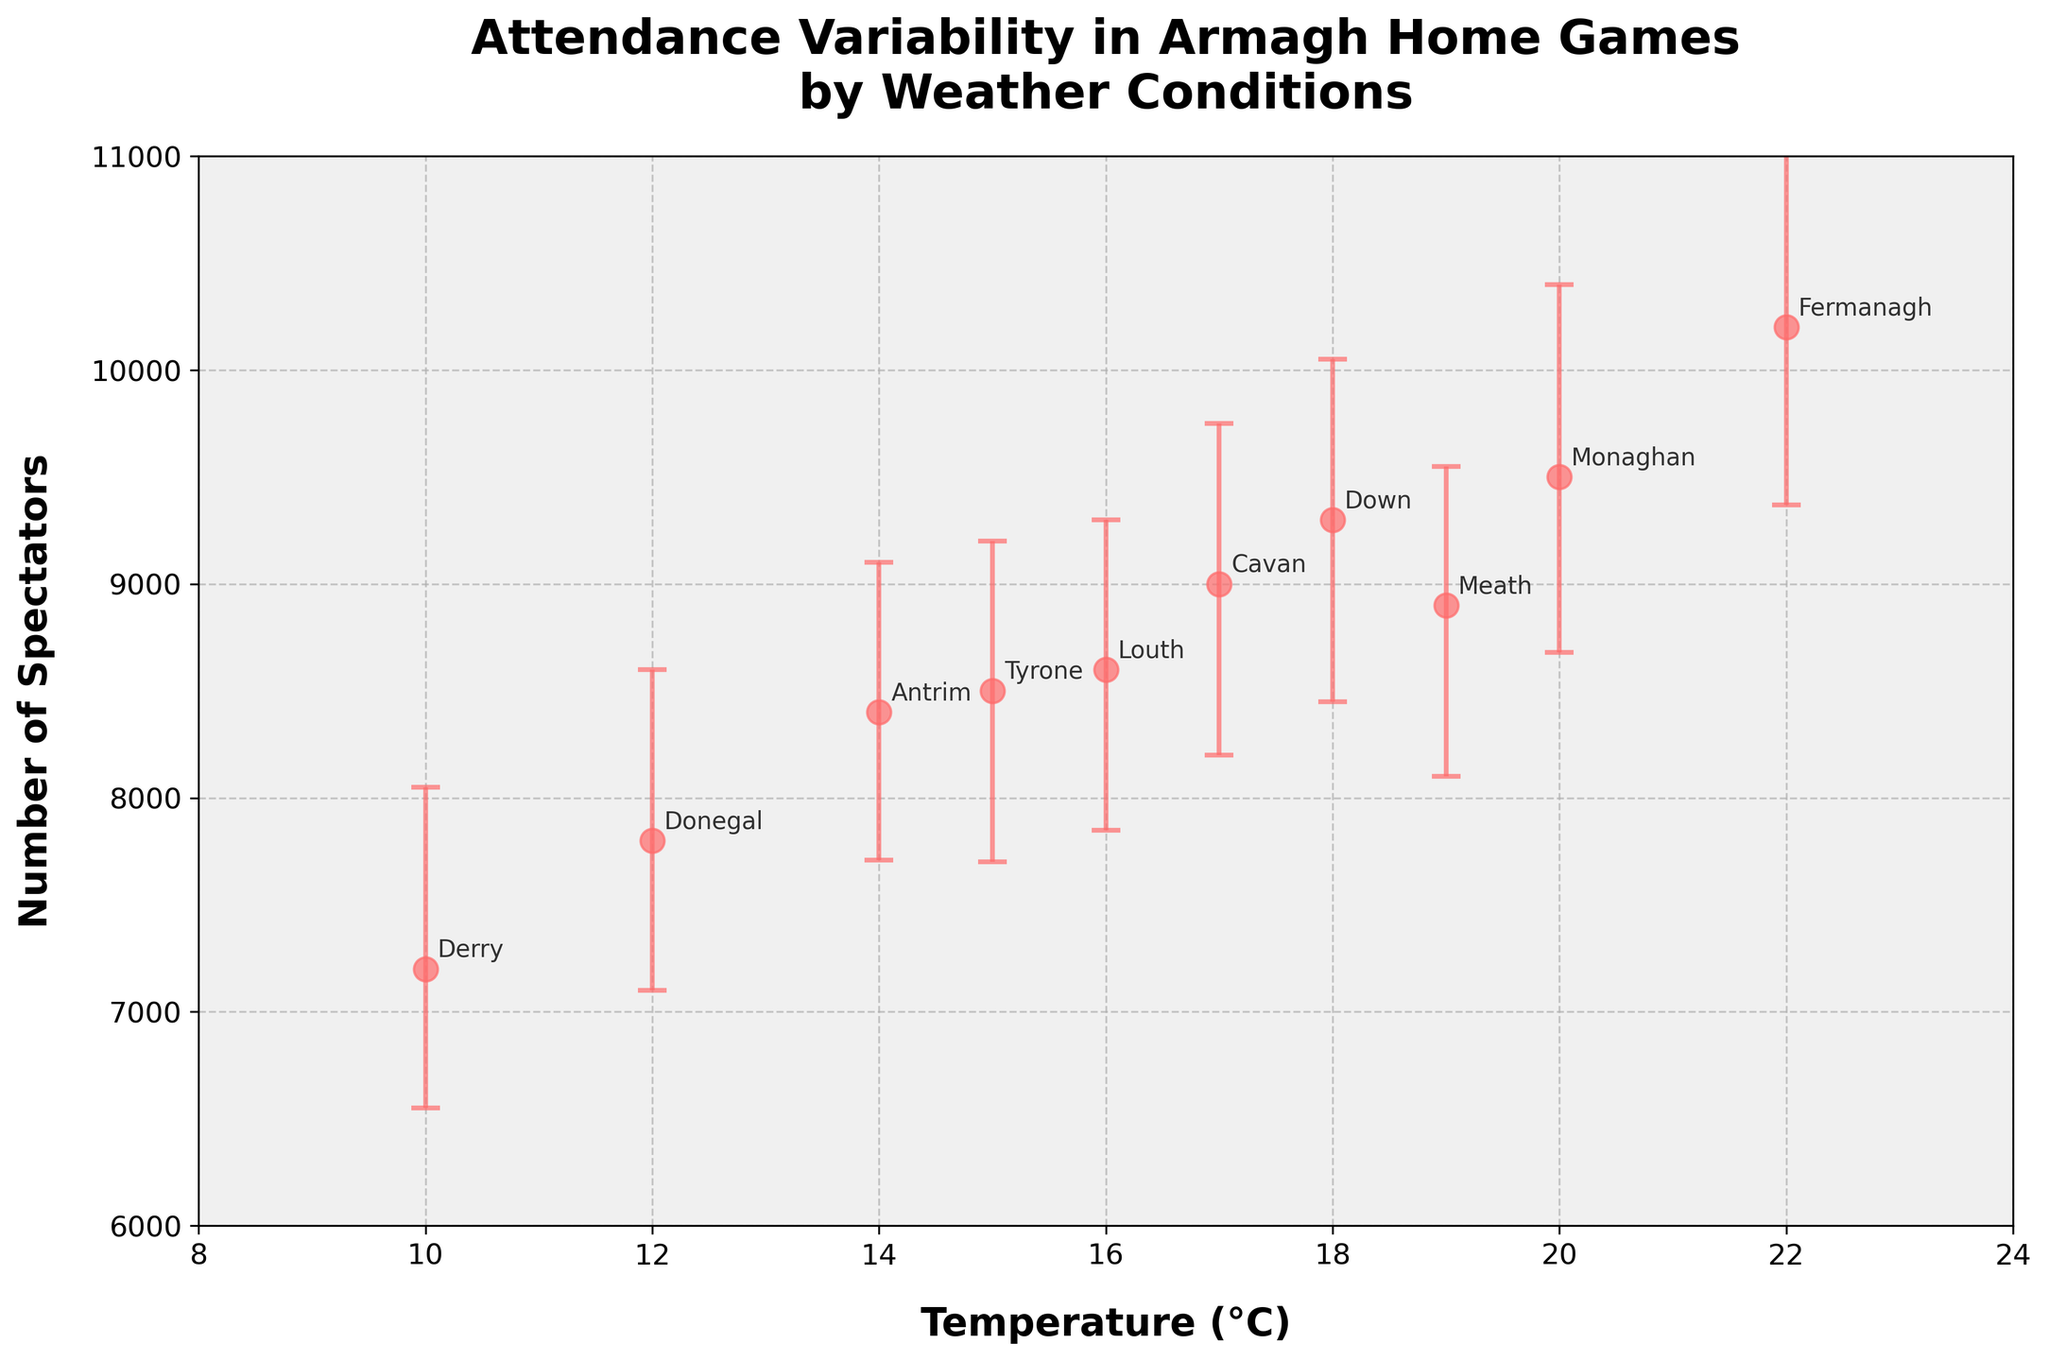What is the title of the plot? The title is found at the top of the figure, summarizing the main content or focus of the plot. Here, it is clearly stated in bold, larger font.
Answer: Attendance Variability in Armagh Home Games by Weather Conditions What is the highest number of spectators recorded, and at what temperature did this occur? Identify the point with the highest y-coordinate (Number of Spectators), then locate its corresponding x-coordinate (Temperature).
Answer: 10200, 22°C What is the general trend between temperature and the number of spectators? Observe the scatter points and see if there's a pattern. Generally, as temperature increases, the number of spectators also increases.
Answer: Positive correlation Which game had the lowest attendance and at what temperature? Look for the point with the lowest y-coordinate (Number of Spectators) and find its label and x-coordinate (Temperature). The game vs. Derry has the lowest attendance.
Answer: Armagh vs. Derry, 10°C What is the average number of spectators across all games? Sum the number of spectators for all games and divide by the number of games (10 games in total). Calculation: (8500 + 9300 + 7800 + 9500 + 7200 + 10200 + 9000 + 8400 + 8600 + 8900) / 10.
Answer: 8830 What is the range of temperatures in the plot? Identify the lowest and highest x-coordinates (Temperatures) to determine the range. The lowest temperature is 10°C and the highest is 22°C.
Answer: 10°C to 22°C Which game has the largest error bar range for the number of spectators? Compare the combined lengths of both the lower and upper error bars for each game to find the longest one. The game vs. Derry has the largest error bar range (650 + 850 = 1500).
Answer: Armagh vs. Derry At what temperature is the attendance most variable? Look for the temperature with the most significant combined error bar range (sum of lower and upper error bars). The game vs. Derry shows the highest variability at 10°C.
Answer: 10°C How many games had an attendance of 9000 or more spectators? Count the number of points with y-coordinate (Number of Spectators) 9000 or higher. There are five games (vs. Down, Monaghan, Fermanagh, Cavan, and Meath).
Answer: 5 games At what temperature were there the fewest spectators, and how many fewer were there compared to the game with the most spectators? Identify the temperature with the lowest y-coordinate and calculate the difference in the number of spectators between this game and the game with the highest y-coordinate. For the game vs. Derry at 10°C (7200 spectators), the difference from the highest attendance (10200 spectators at 22°C) is 10200 - 7200 = 3000.
Answer: 10°C, 3000 fewer 